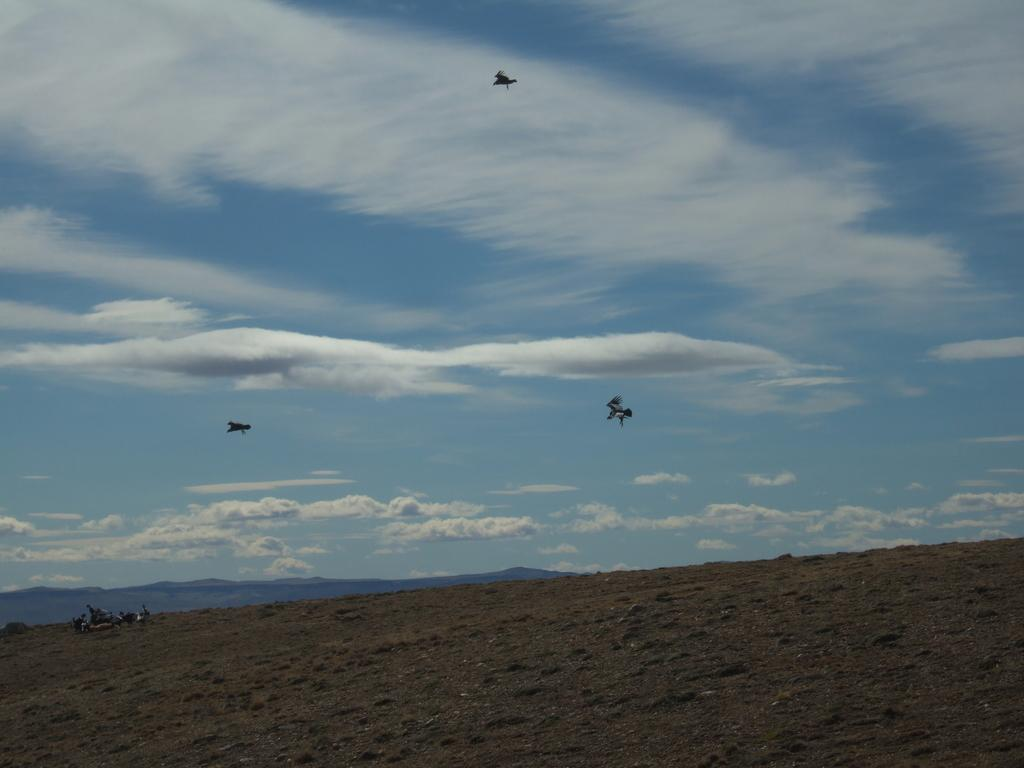What type of natural formation can be seen in the image? There are mountains in the image. What else is visible in the sky in the image? There are birds in the sky in the image. What type of flesh can be seen hanging from the mountains in the image? There is no flesh present in the image; it features mountains and birds in the sky. What type of coach is visible in the image? There is no coach present in the image. 